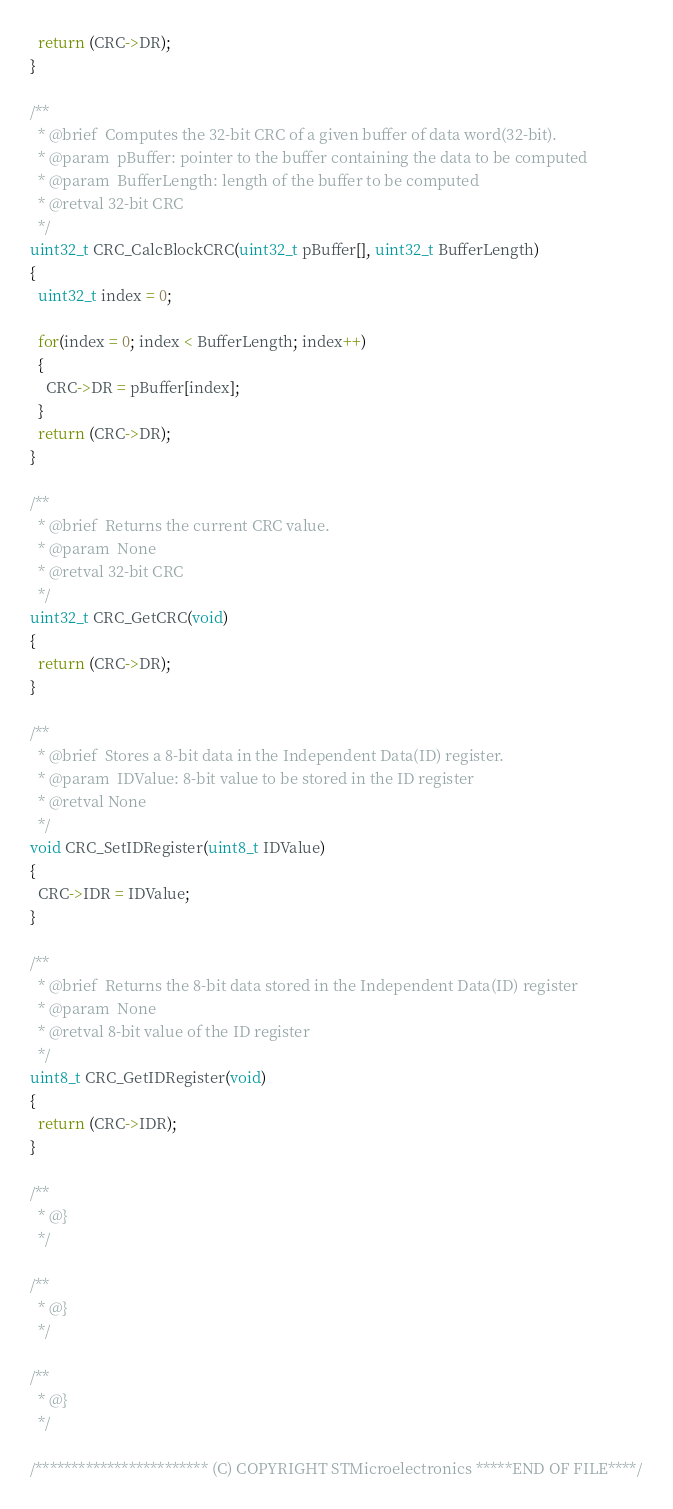Convert code to text. <code><loc_0><loc_0><loc_500><loc_500><_C_>  return (CRC->DR);
}

/**
  * @brief  Computes the 32-bit CRC of a given buffer of data word(32-bit).
  * @param  pBuffer: pointer to the buffer containing the data to be computed
  * @param  BufferLength: length of the buffer to be computed
  * @retval 32-bit CRC
  */
uint32_t CRC_CalcBlockCRC(uint32_t pBuffer[], uint32_t BufferLength)
{
  uint32_t index = 0;

  for(index = 0; index < BufferLength; index++)
  {
    CRC->DR = pBuffer[index];
  }
  return (CRC->DR);
}

/**
  * @brief  Returns the current CRC value.
  * @param  None
  * @retval 32-bit CRC
  */
uint32_t CRC_GetCRC(void)
{
  return (CRC->DR);
}

/**
  * @brief  Stores a 8-bit data in the Independent Data(ID) register.
  * @param  IDValue: 8-bit value to be stored in the ID register
  * @retval None
  */
void CRC_SetIDRegister(uint8_t IDValue)
{
  CRC->IDR = IDValue;
}

/**
  * @brief  Returns the 8-bit data stored in the Independent Data(ID) register
  * @param  None
  * @retval 8-bit value of the ID register
  */
uint8_t CRC_GetIDRegister(void)
{
  return (CRC->IDR);
}

/**
  * @}
  */

/**
  * @}
  */

/**
  * @}
  */

/************************ (C) COPYRIGHT STMicroelectronics *****END OF FILE****/
</code> 